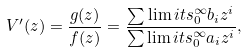<formula> <loc_0><loc_0><loc_500><loc_500>V ^ { \prime } ( z ) = \frac { g ( z ) } { f ( z ) } = \frac { \sum \lim i t s _ { 0 } ^ { \infty } b _ { i } z ^ { i } } { \sum \lim i t s _ { 0 } ^ { \infty } a _ { i } z ^ { i } } ,</formula> 